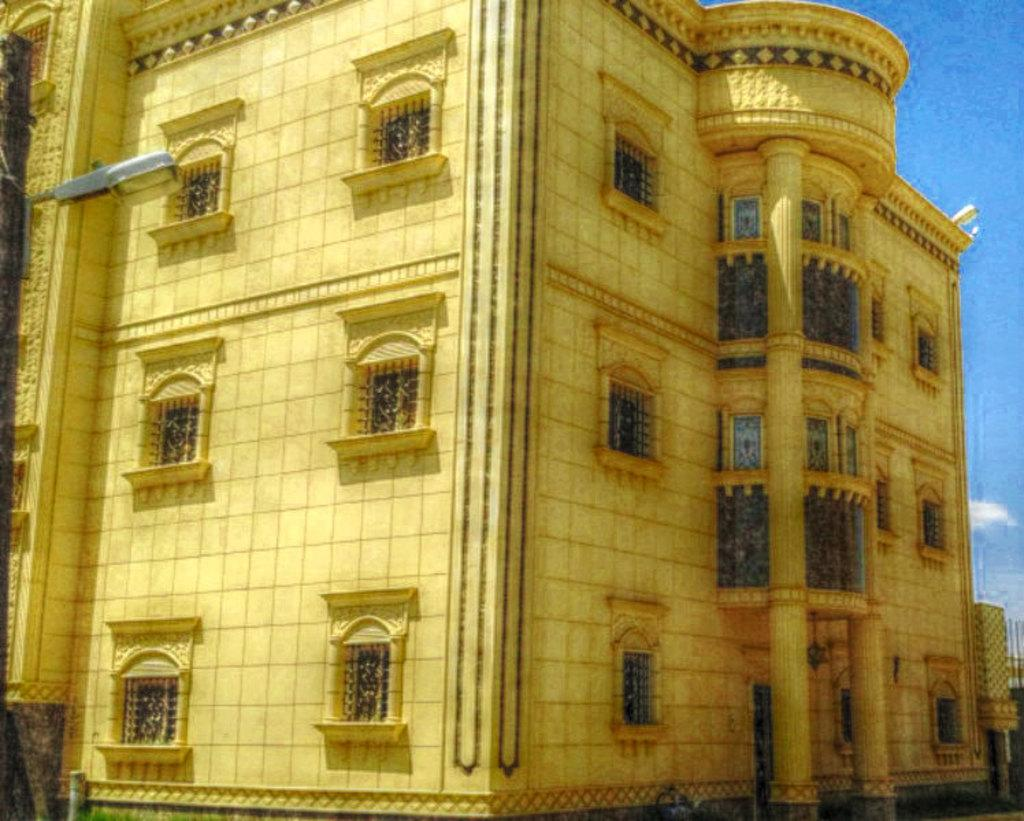What type of structure is present in the image? There is a building in the image. Where is the street light located in the image? The street light is on the left side of the image. What part of the natural environment is visible in the image? The sky is visible at the top right of the image. What type of animal is sleeping on the roof of the building in the image? There is no animal present in the image, and the image does not show any sleeping creatures. 